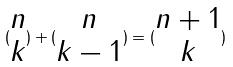<formula> <loc_0><loc_0><loc_500><loc_500>( \begin{matrix} n \\ k \end{matrix} ) + ( \begin{matrix} n \\ k - 1 \end{matrix} ) = ( \begin{matrix} n + 1 \\ k \end{matrix} )</formula> 